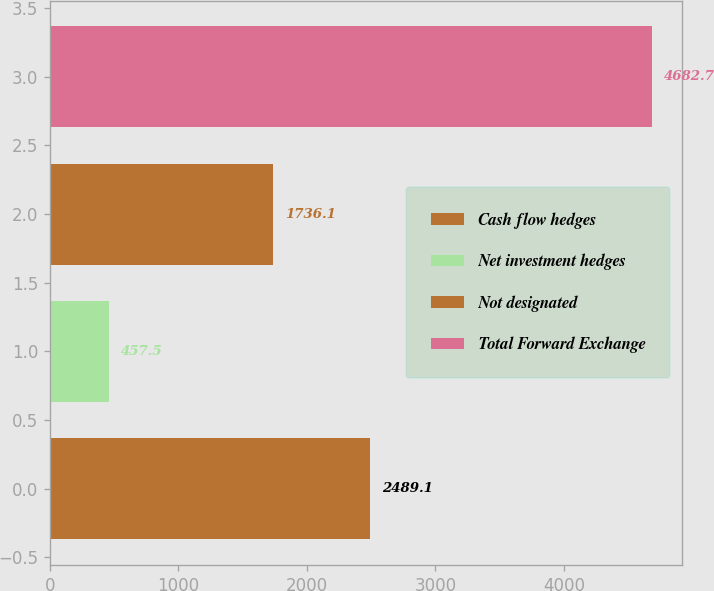<chart> <loc_0><loc_0><loc_500><loc_500><bar_chart><fcel>Cash flow hedges<fcel>Net investment hedges<fcel>Not designated<fcel>Total Forward Exchange<nl><fcel>2489.1<fcel>457.5<fcel>1736.1<fcel>4682.7<nl></chart> 